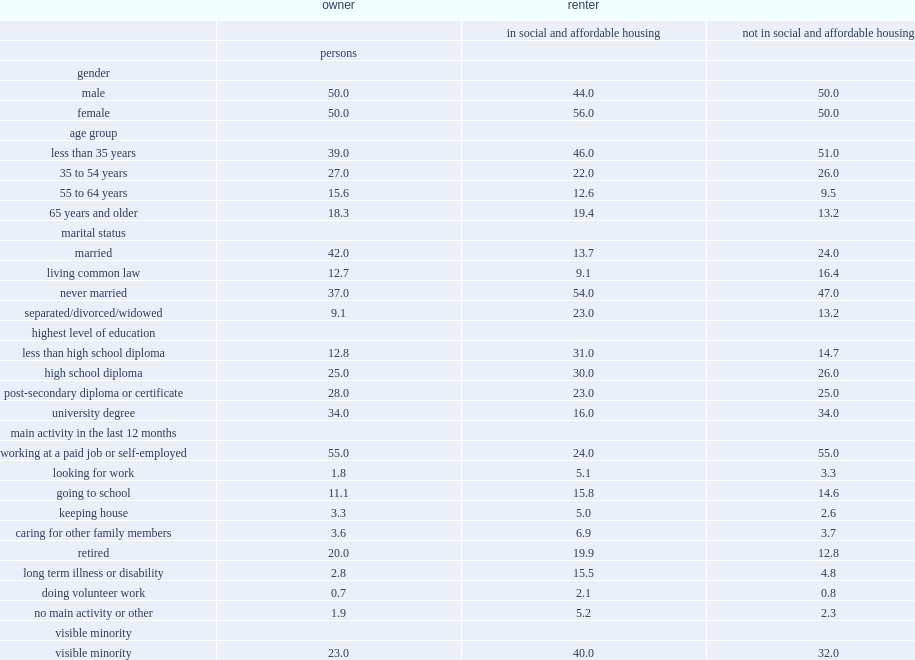Which group of people has a higher proportion of residents among renters in social and affordable housing? women or men? Female. What percent of renters in social and affordable housing were married? 13.7. What percent of renters not in social and affordable housing were married? 24.0. Which type of renter has a higher proportion of seniors (65 years and older) ? renters in social and affordable housing or other renters? In social and affordable housing. For renters not in social and affordable housing, what is the proportion of visible minority population? 32.0. How many percent of renters in social and affordable housing was represented by indigenous peoples (first nations people living off reserve, metis and inuit)? 9.4. What percent of renters in social and affordable housing reported working at a job or being self-employed during the last 12 months? 24.0. What is the proportion for owners reported working at a job or being self-employed during the last 12 months? 55.0. What percent of renters not living in social and affordable housing reported a long-term illness or disability. 4.8. Would you mind parsing the complete table? {'header': ['', 'owner', 'renter', ''], 'rows': [['', '', 'in social and affordable housing', 'not in social and affordable housing'], ['', 'persons', '', ''], ['gender', '', '', ''], ['male', '50.0', '44.0', '50.0'], ['female', '50.0', '56.0', '50.0'], ['age group', '', '', ''], ['less than 35 years', '39.0', '46.0', '51.0'], ['35 to 54 years', '27.0', '22.0', '26.0'], ['55 to 64 years', '15.6', '12.6', '9.5'], ['65 years and older', '18.3', '19.4', '13.2'], ['marital status', '', '', ''], ['married', '42.0', '13.7', '24.0'], ['living common law', '12.7', '9.1', '16.4'], ['never married', '37.0', '54.0', '47.0'], ['separated/divorced/widowed', '9.1', '23.0', '13.2'], ['highest level of education', '', '', ''], ['less than high school diploma', '12.8', '31.0', '14.7'], ['high school diploma', '25.0', '30.0', '26.0'], ['post-secondary diploma or certificate', '28.0', '23.0', '25.0'], ['university degree', '34.0', '16.0', '34.0'], ['main activity in the last 12 months', '', '', ''], ['working at a paid job or self-employed', '55.0', '24.0', '55.0'], ['looking for work', '1.8', '5.1', '3.3'], ['going to school', '11.1', '15.8', '14.6'], ['keeping house', '3.3', '5.0', '2.6'], ['caring for other family members', '3.6', '6.9', '3.7'], ['retired', '20.0', '19.9', '12.8'], ['long term illness or disability', '2.8', '15.5', '4.8'], ['doing volunteer work', '0.7', '2.1', '0.8'], ['no main activity or other', '1.9', '5.2', '2.3'], ['visible minority', '', '', ''], ['visible minority', '23.0', '40.0', '32.0'], ['not a visible minority', '77.0', '60.0', '68.0'], ['indigenous identity', '', '', ''], ['indigenous', '3.1', '9.4', '3.8'], ['non-indigenous', '96.9', '90.6', '96.2'], ['veteran status', '', '', ''], ['veteran or currently a member of canadian armed forces', '2.2', '2.5', '2.3'], ['never had canadian military service', '97.8', '97.5', '97.7']]} 